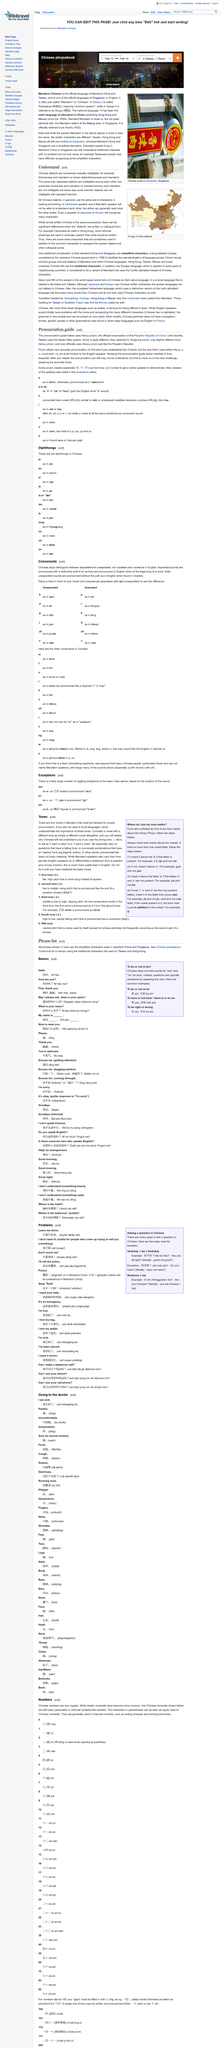Identify some key points in this picture. The Hanyu pinyin system is used in the pronunciation guide. Mandarin Chinese requires the use of four tones for proper pronunciation. Until recently, Taiwan used the Wade-Giles system for pronunciation, which has now been replaced by the Pinyin system. The text discusses the various Chinese dialects and the dialect it is about is not specified. Japanese speakers are able to recognize some Chinese characters. 